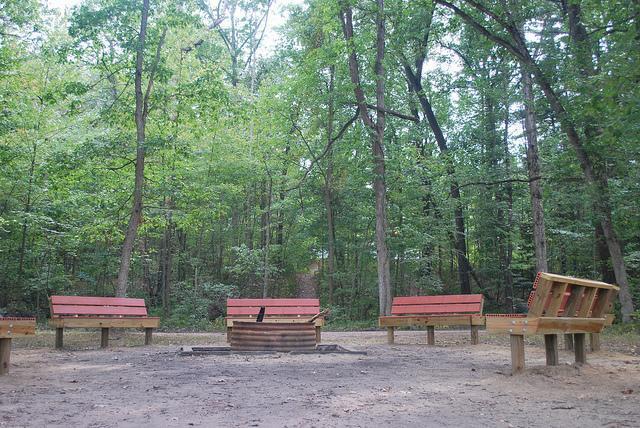How many benches are in the park?
Give a very brief answer. 5. How many benches are depicted?
Give a very brief answer. 4. How many benches are in the photo?
Give a very brief answer. 4. 